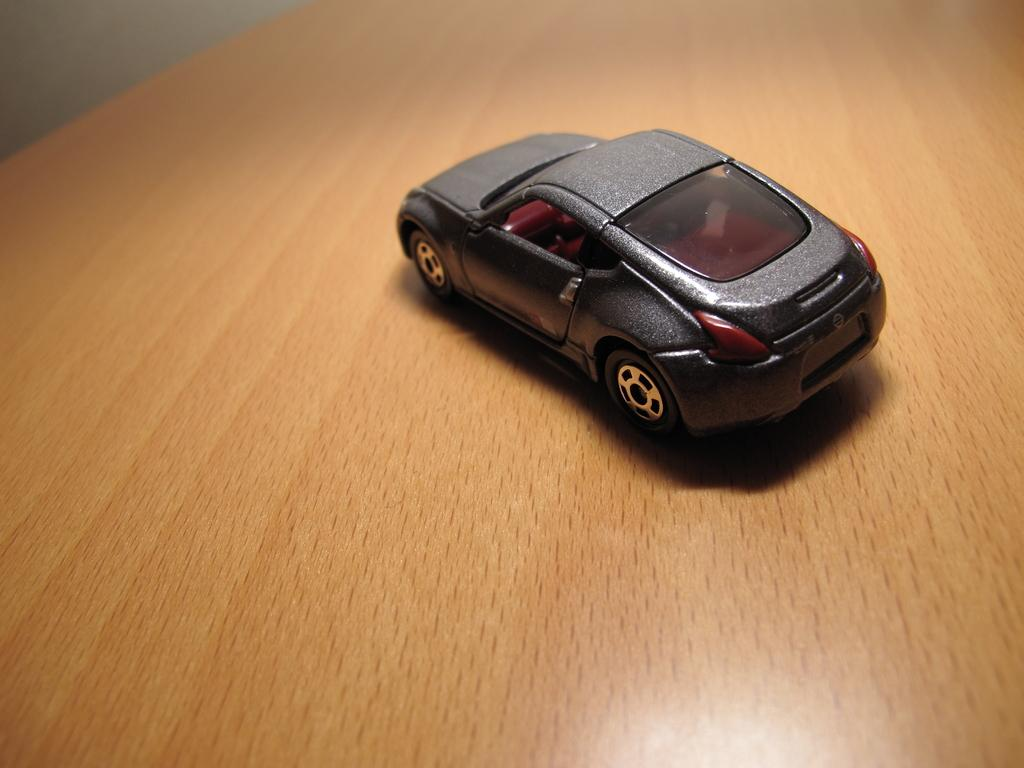What is the main object in the image? There is a toy car in the image. Where is the toy car located? The toy car is on a wooden table. What can be seen in the background of the image? There is a wall in the background of the image. What type of fan is visible in the image? There is no fan present in the image. What is the reason for the protest in the image? There is no protest depicted in the image. 